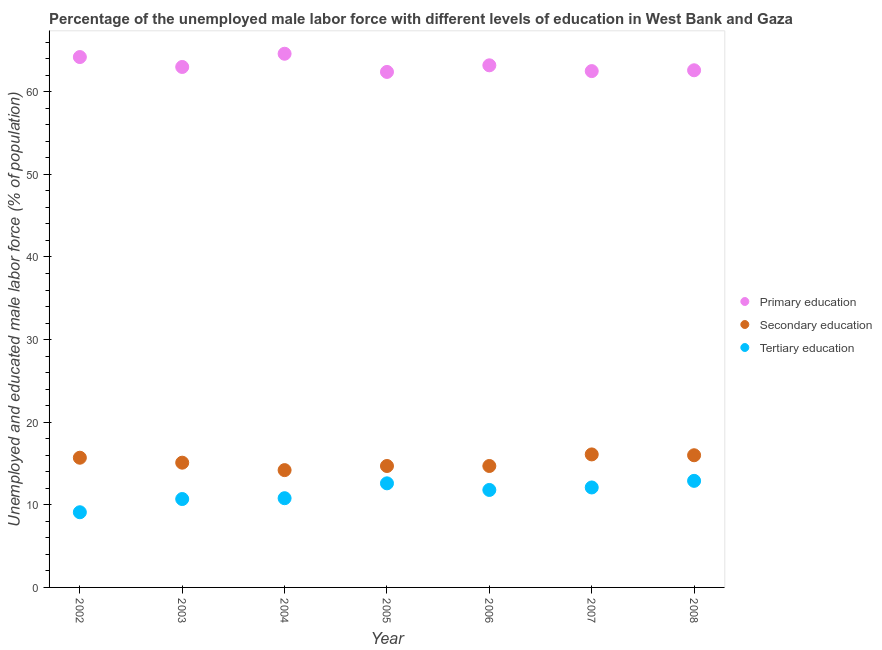How many different coloured dotlines are there?
Ensure brevity in your answer.  3. Is the number of dotlines equal to the number of legend labels?
Provide a succinct answer. Yes. What is the percentage of male labor force who received tertiary education in 2008?
Make the answer very short. 12.9. Across all years, what is the maximum percentage of male labor force who received tertiary education?
Give a very brief answer. 12.9. Across all years, what is the minimum percentage of male labor force who received secondary education?
Give a very brief answer. 14.2. In which year was the percentage of male labor force who received primary education minimum?
Offer a terse response. 2005. What is the total percentage of male labor force who received secondary education in the graph?
Make the answer very short. 106.5. What is the difference between the percentage of male labor force who received secondary education in 2003 and that in 2005?
Keep it short and to the point. 0.4. What is the difference between the percentage of male labor force who received secondary education in 2002 and the percentage of male labor force who received primary education in 2008?
Your response must be concise. -46.9. What is the average percentage of male labor force who received secondary education per year?
Your answer should be compact. 15.21. In the year 2006, what is the difference between the percentage of male labor force who received tertiary education and percentage of male labor force who received secondary education?
Give a very brief answer. -2.9. In how many years, is the percentage of male labor force who received primary education greater than 38 %?
Ensure brevity in your answer.  7. What is the ratio of the percentage of male labor force who received tertiary education in 2002 to that in 2007?
Make the answer very short. 0.75. Is the difference between the percentage of male labor force who received tertiary education in 2002 and 2006 greater than the difference between the percentage of male labor force who received primary education in 2002 and 2006?
Provide a succinct answer. No. What is the difference between the highest and the second highest percentage of male labor force who received primary education?
Ensure brevity in your answer.  0.4. What is the difference between the highest and the lowest percentage of male labor force who received secondary education?
Your answer should be very brief. 1.9. In how many years, is the percentage of male labor force who received secondary education greater than the average percentage of male labor force who received secondary education taken over all years?
Make the answer very short. 3. Does the percentage of male labor force who received secondary education monotonically increase over the years?
Your answer should be very brief. No. Is the percentage of male labor force who received secondary education strictly less than the percentage of male labor force who received primary education over the years?
Your answer should be compact. Yes. Where does the legend appear in the graph?
Provide a short and direct response. Center right. How are the legend labels stacked?
Provide a succinct answer. Vertical. What is the title of the graph?
Provide a short and direct response. Percentage of the unemployed male labor force with different levels of education in West Bank and Gaza. Does "Ores and metals" appear as one of the legend labels in the graph?
Your answer should be compact. No. What is the label or title of the X-axis?
Offer a very short reply. Year. What is the label or title of the Y-axis?
Keep it short and to the point. Unemployed and educated male labor force (% of population). What is the Unemployed and educated male labor force (% of population) of Primary education in 2002?
Provide a succinct answer. 64.2. What is the Unemployed and educated male labor force (% of population) in Secondary education in 2002?
Give a very brief answer. 15.7. What is the Unemployed and educated male labor force (% of population) in Tertiary education in 2002?
Give a very brief answer. 9.1. What is the Unemployed and educated male labor force (% of population) in Secondary education in 2003?
Provide a succinct answer. 15.1. What is the Unemployed and educated male labor force (% of population) of Tertiary education in 2003?
Ensure brevity in your answer.  10.7. What is the Unemployed and educated male labor force (% of population) in Primary education in 2004?
Your answer should be compact. 64.6. What is the Unemployed and educated male labor force (% of population) in Secondary education in 2004?
Ensure brevity in your answer.  14.2. What is the Unemployed and educated male labor force (% of population) in Tertiary education in 2004?
Provide a short and direct response. 10.8. What is the Unemployed and educated male labor force (% of population) in Primary education in 2005?
Ensure brevity in your answer.  62.4. What is the Unemployed and educated male labor force (% of population) of Secondary education in 2005?
Offer a terse response. 14.7. What is the Unemployed and educated male labor force (% of population) in Tertiary education in 2005?
Offer a very short reply. 12.6. What is the Unemployed and educated male labor force (% of population) in Primary education in 2006?
Your response must be concise. 63.2. What is the Unemployed and educated male labor force (% of population) of Secondary education in 2006?
Your response must be concise. 14.7. What is the Unemployed and educated male labor force (% of population) in Tertiary education in 2006?
Your answer should be very brief. 11.8. What is the Unemployed and educated male labor force (% of population) in Primary education in 2007?
Offer a very short reply. 62.5. What is the Unemployed and educated male labor force (% of population) in Secondary education in 2007?
Your response must be concise. 16.1. What is the Unemployed and educated male labor force (% of population) in Tertiary education in 2007?
Offer a very short reply. 12.1. What is the Unemployed and educated male labor force (% of population) of Primary education in 2008?
Make the answer very short. 62.6. What is the Unemployed and educated male labor force (% of population) of Secondary education in 2008?
Your response must be concise. 16. What is the Unemployed and educated male labor force (% of population) of Tertiary education in 2008?
Make the answer very short. 12.9. Across all years, what is the maximum Unemployed and educated male labor force (% of population) of Primary education?
Ensure brevity in your answer.  64.6. Across all years, what is the maximum Unemployed and educated male labor force (% of population) of Secondary education?
Provide a succinct answer. 16.1. Across all years, what is the maximum Unemployed and educated male labor force (% of population) in Tertiary education?
Your answer should be compact. 12.9. Across all years, what is the minimum Unemployed and educated male labor force (% of population) in Primary education?
Offer a terse response. 62.4. Across all years, what is the minimum Unemployed and educated male labor force (% of population) of Secondary education?
Ensure brevity in your answer.  14.2. Across all years, what is the minimum Unemployed and educated male labor force (% of population) in Tertiary education?
Make the answer very short. 9.1. What is the total Unemployed and educated male labor force (% of population) in Primary education in the graph?
Provide a succinct answer. 442.5. What is the total Unemployed and educated male labor force (% of population) in Secondary education in the graph?
Your answer should be compact. 106.5. What is the total Unemployed and educated male labor force (% of population) of Tertiary education in the graph?
Give a very brief answer. 80. What is the difference between the Unemployed and educated male labor force (% of population) in Tertiary education in 2002 and that in 2003?
Give a very brief answer. -1.6. What is the difference between the Unemployed and educated male labor force (% of population) in Primary education in 2002 and that in 2004?
Provide a short and direct response. -0.4. What is the difference between the Unemployed and educated male labor force (% of population) of Tertiary education in 2002 and that in 2004?
Your answer should be compact. -1.7. What is the difference between the Unemployed and educated male labor force (% of population) in Primary education in 2002 and that in 2005?
Ensure brevity in your answer.  1.8. What is the difference between the Unemployed and educated male labor force (% of population) in Tertiary education in 2002 and that in 2005?
Keep it short and to the point. -3.5. What is the difference between the Unemployed and educated male labor force (% of population) in Primary education in 2002 and that in 2006?
Make the answer very short. 1. What is the difference between the Unemployed and educated male labor force (% of population) of Secondary education in 2002 and that in 2006?
Offer a terse response. 1. What is the difference between the Unemployed and educated male labor force (% of population) in Tertiary education in 2002 and that in 2007?
Your answer should be very brief. -3. What is the difference between the Unemployed and educated male labor force (% of population) of Primary education in 2002 and that in 2008?
Your answer should be compact. 1.6. What is the difference between the Unemployed and educated male labor force (% of population) of Secondary education in 2002 and that in 2008?
Offer a very short reply. -0.3. What is the difference between the Unemployed and educated male labor force (% of population) in Tertiary education in 2003 and that in 2004?
Provide a short and direct response. -0.1. What is the difference between the Unemployed and educated male labor force (% of population) of Primary education in 2003 and that in 2005?
Provide a short and direct response. 0.6. What is the difference between the Unemployed and educated male labor force (% of population) of Secondary education in 2003 and that in 2005?
Offer a terse response. 0.4. What is the difference between the Unemployed and educated male labor force (% of population) in Primary education in 2003 and that in 2006?
Offer a very short reply. -0.2. What is the difference between the Unemployed and educated male labor force (% of population) of Secondary education in 2003 and that in 2006?
Ensure brevity in your answer.  0.4. What is the difference between the Unemployed and educated male labor force (% of population) of Tertiary education in 2003 and that in 2006?
Give a very brief answer. -1.1. What is the difference between the Unemployed and educated male labor force (% of population) of Primary education in 2003 and that in 2007?
Give a very brief answer. 0.5. What is the difference between the Unemployed and educated male labor force (% of population) of Secondary education in 2003 and that in 2007?
Your answer should be very brief. -1. What is the difference between the Unemployed and educated male labor force (% of population) of Tertiary education in 2003 and that in 2007?
Ensure brevity in your answer.  -1.4. What is the difference between the Unemployed and educated male labor force (% of population) in Primary education in 2004 and that in 2007?
Give a very brief answer. 2.1. What is the difference between the Unemployed and educated male labor force (% of population) in Secondary education in 2004 and that in 2007?
Keep it short and to the point. -1.9. What is the difference between the Unemployed and educated male labor force (% of population) of Secondary education in 2004 and that in 2008?
Give a very brief answer. -1.8. What is the difference between the Unemployed and educated male labor force (% of population) of Primary education in 2005 and that in 2007?
Offer a very short reply. -0.1. What is the difference between the Unemployed and educated male labor force (% of population) of Secondary education in 2005 and that in 2008?
Provide a short and direct response. -1.3. What is the difference between the Unemployed and educated male labor force (% of population) of Tertiary education in 2005 and that in 2008?
Your answer should be compact. -0.3. What is the difference between the Unemployed and educated male labor force (% of population) in Secondary education in 2006 and that in 2007?
Your answer should be compact. -1.4. What is the difference between the Unemployed and educated male labor force (% of population) of Tertiary education in 2006 and that in 2008?
Give a very brief answer. -1.1. What is the difference between the Unemployed and educated male labor force (% of population) in Primary education in 2007 and that in 2008?
Offer a very short reply. -0.1. What is the difference between the Unemployed and educated male labor force (% of population) of Tertiary education in 2007 and that in 2008?
Your answer should be compact. -0.8. What is the difference between the Unemployed and educated male labor force (% of population) in Primary education in 2002 and the Unemployed and educated male labor force (% of population) in Secondary education in 2003?
Your answer should be compact. 49.1. What is the difference between the Unemployed and educated male labor force (% of population) in Primary education in 2002 and the Unemployed and educated male labor force (% of population) in Tertiary education in 2003?
Keep it short and to the point. 53.5. What is the difference between the Unemployed and educated male labor force (% of population) of Secondary education in 2002 and the Unemployed and educated male labor force (% of population) of Tertiary education in 2003?
Your answer should be very brief. 5. What is the difference between the Unemployed and educated male labor force (% of population) of Primary education in 2002 and the Unemployed and educated male labor force (% of population) of Secondary education in 2004?
Your answer should be compact. 50. What is the difference between the Unemployed and educated male labor force (% of population) in Primary education in 2002 and the Unemployed and educated male labor force (% of population) in Tertiary education in 2004?
Your answer should be very brief. 53.4. What is the difference between the Unemployed and educated male labor force (% of population) of Secondary education in 2002 and the Unemployed and educated male labor force (% of population) of Tertiary education in 2004?
Your answer should be compact. 4.9. What is the difference between the Unemployed and educated male labor force (% of population) in Primary education in 2002 and the Unemployed and educated male labor force (% of population) in Secondary education in 2005?
Offer a terse response. 49.5. What is the difference between the Unemployed and educated male labor force (% of population) in Primary education in 2002 and the Unemployed and educated male labor force (% of population) in Tertiary education in 2005?
Make the answer very short. 51.6. What is the difference between the Unemployed and educated male labor force (% of population) of Primary education in 2002 and the Unemployed and educated male labor force (% of population) of Secondary education in 2006?
Provide a succinct answer. 49.5. What is the difference between the Unemployed and educated male labor force (% of population) in Primary education in 2002 and the Unemployed and educated male labor force (% of population) in Tertiary education in 2006?
Your answer should be very brief. 52.4. What is the difference between the Unemployed and educated male labor force (% of population) in Primary education in 2002 and the Unemployed and educated male labor force (% of population) in Secondary education in 2007?
Give a very brief answer. 48.1. What is the difference between the Unemployed and educated male labor force (% of population) in Primary education in 2002 and the Unemployed and educated male labor force (% of population) in Tertiary education in 2007?
Provide a short and direct response. 52.1. What is the difference between the Unemployed and educated male labor force (% of population) of Secondary education in 2002 and the Unemployed and educated male labor force (% of population) of Tertiary education in 2007?
Your answer should be very brief. 3.6. What is the difference between the Unemployed and educated male labor force (% of population) in Primary education in 2002 and the Unemployed and educated male labor force (% of population) in Secondary education in 2008?
Give a very brief answer. 48.2. What is the difference between the Unemployed and educated male labor force (% of population) in Primary education in 2002 and the Unemployed and educated male labor force (% of population) in Tertiary education in 2008?
Your response must be concise. 51.3. What is the difference between the Unemployed and educated male labor force (% of population) of Primary education in 2003 and the Unemployed and educated male labor force (% of population) of Secondary education in 2004?
Make the answer very short. 48.8. What is the difference between the Unemployed and educated male labor force (% of population) of Primary education in 2003 and the Unemployed and educated male labor force (% of population) of Tertiary education in 2004?
Your answer should be compact. 52.2. What is the difference between the Unemployed and educated male labor force (% of population) in Secondary education in 2003 and the Unemployed and educated male labor force (% of population) in Tertiary education in 2004?
Your answer should be compact. 4.3. What is the difference between the Unemployed and educated male labor force (% of population) of Primary education in 2003 and the Unemployed and educated male labor force (% of population) of Secondary education in 2005?
Offer a very short reply. 48.3. What is the difference between the Unemployed and educated male labor force (% of population) of Primary education in 2003 and the Unemployed and educated male labor force (% of population) of Tertiary education in 2005?
Your response must be concise. 50.4. What is the difference between the Unemployed and educated male labor force (% of population) in Primary education in 2003 and the Unemployed and educated male labor force (% of population) in Secondary education in 2006?
Make the answer very short. 48.3. What is the difference between the Unemployed and educated male labor force (% of population) of Primary education in 2003 and the Unemployed and educated male labor force (% of population) of Tertiary education in 2006?
Keep it short and to the point. 51.2. What is the difference between the Unemployed and educated male labor force (% of population) of Secondary education in 2003 and the Unemployed and educated male labor force (% of population) of Tertiary education in 2006?
Keep it short and to the point. 3.3. What is the difference between the Unemployed and educated male labor force (% of population) in Primary education in 2003 and the Unemployed and educated male labor force (% of population) in Secondary education in 2007?
Ensure brevity in your answer.  46.9. What is the difference between the Unemployed and educated male labor force (% of population) in Primary education in 2003 and the Unemployed and educated male labor force (% of population) in Tertiary education in 2007?
Ensure brevity in your answer.  50.9. What is the difference between the Unemployed and educated male labor force (% of population) in Secondary education in 2003 and the Unemployed and educated male labor force (% of population) in Tertiary education in 2007?
Your answer should be very brief. 3. What is the difference between the Unemployed and educated male labor force (% of population) in Primary education in 2003 and the Unemployed and educated male labor force (% of population) in Tertiary education in 2008?
Keep it short and to the point. 50.1. What is the difference between the Unemployed and educated male labor force (% of population) in Primary education in 2004 and the Unemployed and educated male labor force (% of population) in Secondary education in 2005?
Keep it short and to the point. 49.9. What is the difference between the Unemployed and educated male labor force (% of population) of Primary education in 2004 and the Unemployed and educated male labor force (% of population) of Tertiary education in 2005?
Give a very brief answer. 52. What is the difference between the Unemployed and educated male labor force (% of population) in Secondary education in 2004 and the Unemployed and educated male labor force (% of population) in Tertiary education in 2005?
Your response must be concise. 1.6. What is the difference between the Unemployed and educated male labor force (% of population) in Primary education in 2004 and the Unemployed and educated male labor force (% of population) in Secondary education in 2006?
Your answer should be compact. 49.9. What is the difference between the Unemployed and educated male labor force (% of population) in Primary education in 2004 and the Unemployed and educated male labor force (% of population) in Tertiary education in 2006?
Keep it short and to the point. 52.8. What is the difference between the Unemployed and educated male labor force (% of population) in Secondary education in 2004 and the Unemployed and educated male labor force (% of population) in Tertiary education in 2006?
Offer a very short reply. 2.4. What is the difference between the Unemployed and educated male labor force (% of population) of Primary education in 2004 and the Unemployed and educated male labor force (% of population) of Secondary education in 2007?
Ensure brevity in your answer.  48.5. What is the difference between the Unemployed and educated male labor force (% of population) of Primary education in 2004 and the Unemployed and educated male labor force (% of population) of Tertiary education in 2007?
Your answer should be compact. 52.5. What is the difference between the Unemployed and educated male labor force (% of population) in Primary education in 2004 and the Unemployed and educated male labor force (% of population) in Secondary education in 2008?
Your answer should be very brief. 48.6. What is the difference between the Unemployed and educated male labor force (% of population) in Primary education in 2004 and the Unemployed and educated male labor force (% of population) in Tertiary education in 2008?
Your answer should be very brief. 51.7. What is the difference between the Unemployed and educated male labor force (% of population) of Primary education in 2005 and the Unemployed and educated male labor force (% of population) of Secondary education in 2006?
Offer a terse response. 47.7. What is the difference between the Unemployed and educated male labor force (% of population) in Primary education in 2005 and the Unemployed and educated male labor force (% of population) in Tertiary education in 2006?
Give a very brief answer. 50.6. What is the difference between the Unemployed and educated male labor force (% of population) in Primary education in 2005 and the Unemployed and educated male labor force (% of population) in Secondary education in 2007?
Offer a very short reply. 46.3. What is the difference between the Unemployed and educated male labor force (% of population) of Primary education in 2005 and the Unemployed and educated male labor force (% of population) of Tertiary education in 2007?
Give a very brief answer. 50.3. What is the difference between the Unemployed and educated male labor force (% of population) in Secondary education in 2005 and the Unemployed and educated male labor force (% of population) in Tertiary education in 2007?
Make the answer very short. 2.6. What is the difference between the Unemployed and educated male labor force (% of population) of Primary education in 2005 and the Unemployed and educated male labor force (% of population) of Secondary education in 2008?
Provide a succinct answer. 46.4. What is the difference between the Unemployed and educated male labor force (% of population) of Primary education in 2005 and the Unemployed and educated male labor force (% of population) of Tertiary education in 2008?
Ensure brevity in your answer.  49.5. What is the difference between the Unemployed and educated male labor force (% of population) of Secondary education in 2005 and the Unemployed and educated male labor force (% of population) of Tertiary education in 2008?
Offer a terse response. 1.8. What is the difference between the Unemployed and educated male labor force (% of population) in Primary education in 2006 and the Unemployed and educated male labor force (% of population) in Secondary education in 2007?
Make the answer very short. 47.1. What is the difference between the Unemployed and educated male labor force (% of population) of Primary education in 2006 and the Unemployed and educated male labor force (% of population) of Tertiary education in 2007?
Offer a terse response. 51.1. What is the difference between the Unemployed and educated male labor force (% of population) in Secondary education in 2006 and the Unemployed and educated male labor force (% of population) in Tertiary education in 2007?
Provide a succinct answer. 2.6. What is the difference between the Unemployed and educated male labor force (% of population) of Primary education in 2006 and the Unemployed and educated male labor force (% of population) of Secondary education in 2008?
Your response must be concise. 47.2. What is the difference between the Unemployed and educated male labor force (% of population) of Primary education in 2006 and the Unemployed and educated male labor force (% of population) of Tertiary education in 2008?
Give a very brief answer. 50.3. What is the difference between the Unemployed and educated male labor force (% of population) of Primary education in 2007 and the Unemployed and educated male labor force (% of population) of Secondary education in 2008?
Your response must be concise. 46.5. What is the difference between the Unemployed and educated male labor force (% of population) in Primary education in 2007 and the Unemployed and educated male labor force (% of population) in Tertiary education in 2008?
Keep it short and to the point. 49.6. What is the average Unemployed and educated male labor force (% of population) in Primary education per year?
Your response must be concise. 63.21. What is the average Unemployed and educated male labor force (% of population) in Secondary education per year?
Provide a short and direct response. 15.21. What is the average Unemployed and educated male labor force (% of population) of Tertiary education per year?
Provide a succinct answer. 11.43. In the year 2002, what is the difference between the Unemployed and educated male labor force (% of population) in Primary education and Unemployed and educated male labor force (% of population) in Secondary education?
Make the answer very short. 48.5. In the year 2002, what is the difference between the Unemployed and educated male labor force (% of population) in Primary education and Unemployed and educated male labor force (% of population) in Tertiary education?
Ensure brevity in your answer.  55.1. In the year 2003, what is the difference between the Unemployed and educated male labor force (% of population) in Primary education and Unemployed and educated male labor force (% of population) in Secondary education?
Your answer should be very brief. 47.9. In the year 2003, what is the difference between the Unemployed and educated male labor force (% of population) of Primary education and Unemployed and educated male labor force (% of population) of Tertiary education?
Provide a succinct answer. 52.3. In the year 2003, what is the difference between the Unemployed and educated male labor force (% of population) of Secondary education and Unemployed and educated male labor force (% of population) of Tertiary education?
Offer a very short reply. 4.4. In the year 2004, what is the difference between the Unemployed and educated male labor force (% of population) in Primary education and Unemployed and educated male labor force (% of population) in Secondary education?
Provide a succinct answer. 50.4. In the year 2004, what is the difference between the Unemployed and educated male labor force (% of population) in Primary education and Unemployed and educated male labor force (% of population) in Tertiary education?
Provide a succinct answer. 53.8. In the year 2005, what is the difference between the Unemployed and educated male labor force (% of population) in Primary education and Unemployed and educated male labor force (% of population) in Secondary education?
Your response must be concise. 47.7. In the year 2005, what is the difference between the Unemployed and educated male labor force (% of population) in Primary education and Unemployed and educated male labor force (% of population) in Tertiary education?
Provide a succinct answer. 49.8. In the year 2005, what is the difference between the Unemployed and educated male labor force (% of population) of Secondary education and Unemployed and educated male labor force (% of population) of Tertiary education?
Keep it short and to the point. 2.1. In the year 2006, what is the difference between the Unemployed and educated male labor force (% of population) of Primary education and Unemployed and educated male labor force (% of population) of Secondary education?
Your response must be concise. 48.5. In the year 2006, what is the difference between the Unemployed and educated male labor force (% of population) in Primary education and Unemployed and educated male labor force (% of population) in Tertiary education?
Offer a very short reply. 51.4. In the year 2006, what is the difference between the Unemployed and educated male labor force (% of population) in Secondary education and Unemployed and educated male labor force (% of population) in Tertiary education?
Your response must be concise. 2.9. In the year 2007, what is the difference between the Unemployed and educated male labor force (% of population) in Primary education and Unemployed and educated male labor force (% of population) in Secondary education?
Offer a terse response. 46.4. In the year 2007, what is the difference between the Unemployed and educated male labor force (% of population) of Primary education and Unemployed and educated male labor force (% of population) of Tertiary education?
Provide a succinct answer. 50.4. In the year 2008, what is the difference between the Unemployed and educated male labor force (% of population) of Primary education and Unemployed and educated male labor force (% of population) of Secondary education?
Your answer should be very brief. 46.6. In the year 2008, what is the difference between the Unemployed and educated male labor force (% of population) of Primary education and Unemployed and educated male labor force (% of population) of Tertiary education?
Ensure brevity in your answer.  49.7. What is the ratio of the Unemployed and educated male labor force (% of population) in Secondary education in 2002 to that in 2003?
Your answer should be compact. 1.04. What is the ratio of the Unemployed and educated male labor force (% of population) of Tertiary education in 2002 to that in 2003?
Offer a terse response. 0.85. What is the ratio of the Unemployed and educated male labor force (% of population) of Secondary education in 2002 to that in 2004?
Provide a succinct answer. 1.11. What is the ratio of the Unemployed and educated male labor force (% of population) in Tertiary education in 2002 to that in 2004?
Give a very brief answer. 0.84. What is the ratio of the Unemployed and educated male labor force (% of population) in Primary education in 2002 to that in 2005?
Keep it short and to the point. 1.03. What is the ratio of the Unemployed and educated male labor force (% of population) of Secondary education in 2002 to that in 2005?
Ensure brevity in your answer.  1.07. What is the ratio of the Unemployed and educated male labor force (% of population) in Tertiary education in 2002 to that in 2005?
Keep it short and to the point. 0.72. What is the ratio of the Unemployed and educated male labor force (% of population) of Primary education in 2002 to that in 2006?
Your answer should be very brief. 1.02. What is the ratio of the Unemployed and educated male labor force (% of population) in Secondary education in 2002 to that in 2006?
Give a very brief answer. 1.07. What is the ratio of the Unemployed and educated male labor force (% of population) of Tertiary education in 2002 to that in 2006?
Your answer should be compact. 0.77. What is the ratio of the Unemployed and educated male labor force (% of population) of Primary education in 2002 to that in 2007?
Give a very brief answer. 1.03. What is the ratio of the Unemployed and educated male labor force (% of population) of Secondary education in 2002 to that in 2007?
Provide a short and direct response. 0.98. What is the ratio of the Unemployed and educated male labor force (% of population) in Tertiary education in 2002 to that in 2007?
Your answer should be very brief. 0.75. What is the ratio of the Unemployed and educated male labor force (% of population) of Primary education in 2002 to that in 2008?
Offer a very short reply. 1.03. What is the ratio of the Unemployed and educated male labor force (% of population) in Secondary education in 2002 to that in 2008?
Give a very brief answer. 0.98. What is the ratio of the Unemployed and educated male labor force (% of population) in Tertiary education in 2002 to that in 2008?
Offer a terse response. 0.71. What is the ratio of the Unemployed and educated male labor force (% of population) in Primary education in 2003 to that in 2004?
Offer a terse response. 0.98. What is the ratio of the Unemployed and educated male labor force (% of population) of Secondary education in 2003 to that in 2004?
Offer a very short reply. 1.06. What is the ratio of the Unemployed and educated male labor force (% of population) of Tertiary education in 2003 to that in 2004?
Your answer should be compact. 0.99. What is the ratio of the Unemployed and educated male labor force (% of population) of Primary education in 2003 to that in 2005?
Offer a terse response. 1.01. What is the ratio of the Unemployed and educated male labor force (% of population) of Secondary education in 2003 to that in 2005?
Provide a short and direct response. 1.03. What is the ratio of the Unemployed and educated male labor force (% of population) of Tertiary education in 2003 to that in 2005?
Provide a short and direct response. 0.85. What is the ratio of the Unemployed and educated male labor force (% of population) of Primary education in 2003 to that in 2006?
Give a very brief answer. 1. What is the ratio of the Unemployed and educated male labor force (% of population) of Secondary education in 2003 to that in 2006?
Your response must be concise. 1.03. What is the ratio of the Unemployed and educated male labor force (% of population) of Tertiary education in 2003 to that in 2006?
Your answer should be compact. 0.91. What is the ratio of the Unemployed and educated male labor force (% of population) of Secondary education in 2003 to that in 2007?
Give a very brief answer. 0.94. What is the ratio of the Unemployed and educated male labor force (% of population) in Tertiary education in 2003 to that in 2007?
Make the answer very short. 0.88. What is the ratio of the Unemployed and educated male labor force (% of population) of Primary education in 2003 to that in 2008?
Offer a very short reply. 1.01. What is the ratio of the Unemployed and educated male labor force (% of population) in Secondary education in 2003 to that in 2008?
Provide a succinct answer. 0.94. What is the ratio of the Unemployed and educated male labor force (% of population) in Tertiary education in 2003 to that in 2008?
Offer a very short reply. 0.83. What is the ratio of the Unemployed and educated male labor force (% of population) of Primary education in 2004 to that in 2005?
Keep it short and to the point. 1.04. What is the ratio of the Unemployed and educated male labor force (% of population) of Secondary education in 2004 to that in 2005?
Your response must be concise. 0.97. What is the ratio of the Unemployed and educated male labor force (% of population) of Tertiary education in 2004 to that in 2005?
Keep it short and to the point. 0.86. What is the ratio of the Unemployed and educated male labor force (% of population) in Primary education in 2004 to that in 2006?
Give a very brief answer. 1.02. What is the ratio of the Unemployed and educated male labor force (% of population) of Tertiary education in 2004 to that in 2006?
Your answer should be very brief. 0.92. What is the ratio of the Unemployed and educated male labor force (% of population) of Primary education in 2004 to that in 2007?
Keep it short and to the point. 1.03. What is the ratio of the Unemployed and educated male labor force (% of population) of Secondary education in 2004 to that in 2007?
Offer a terse response. 0.88. What is the ratio of the Unemployed and educated male labor force (% of population) in Tertiary education in 2004 to that in 2007?
Keep it short and to the point. 0.89. What is the ratio of the Unemployed and educated male labor force (% of population) of Primary education in 2004 to that in 2008?
Provide a succinct answer. 1.03. What is the ratio of the Unemployed and educated male labor force (% of population) in Secondary education in 2004 to that in 2008?
Give a very brief answer. 0.89. What is the ratio of the Unemployed and educated male labor force (% of population) of Tertiary education in 2004 to that in 2008?
Give a very brief answer. 0.84. What is the ratio of the Unemployed and educated male labor force (% of population) in Primary education in 2005 to that in 2006?
Offer a very short reply. 0.99. What is the ratio of the Unemployed and educated male labor force (% of population) in Secondary education in 2005 to that in 2006?
Offer a very short reply. 1. What is the ratio of the Unemployed and educated male labor force (% of population) of Tertiary education in 2005 to that in 2006?
Provide a short and direct response. 1.07. What is the ratio of the Unemployed and educated male labor force (% of population) of Primary education in 2005 to that in 2007?
Offer a very short reply. 1. What is the ratio of the Unemployed and educated male labor force (% of population) in Secondary education in 2005 to that in 2007?
Ensure brevity in your answer.  0.91. What is the ratio of the Unemployed and educated male labor force (% of population) in Tertiary education in 2005 to that in 2007?
Give a very brief answer. 1.04. What is the ratio of the Unemployed and educated male labor force (% of population) in Primary education in 2005 to that in 2008?
Provide a succinct answer. 1. What is the ratio of the Unemployed and educated male labor force (% of population) in Secondary education in 2005 to that in 2008?
Keep it short and to the point. 0.92. What is the ratio of the Unemployed and educated male labor force (% of population) in Tertiary education in 2005 to that in 2008?
Make the answer very short. 0.98. What is the ratio of the Unemployed and educated male labor force (% of population) of Primary education in 2006 to that in 2007?
Ensure brevity in your answer.  1.01. What is the ratio of the Unemployed and educated male labor force (% of population) of Secondary education in 2006 to that in 2007?
Keep it short and to the point. 0.91. What is the ratio of the Unemployed and educated male labor force (% of population) in Tertiary education in 2006 to that in 2007?
Give a very brief answer. 0.98. What is the ratio of the Unemployed and educated male labor force (% of population) in Primary education in 2006 to that in 2008?
Keep it short and to the point. 1.01. What is the ratio of the Unemployed and educated male labor force (% of population) of Secondary education in 2006 to that in 2008?
Your answer should be compact. 0.92. What is the ratio of the Unemployed and educated male labor force (% of population) of Tertiary education in 2006 to that in 2008?
Make the answer very short. 0.91. What is the ratio of the Unemployed and educated male labor force (% of population) in Secondary education in 2007 to that in 2008?
Make the answer very short. 1.01. What is the ratio of the Unemployed and educated male labor force (% of population) in Tertiary education in 2007 to that in 2008?
Provide a short and direct response. 0.94. What is the difference between the highest and the second highest Unemployed and educated male labor force (% of population) of Secondary education?
Give a very brief answer. 0.1. 